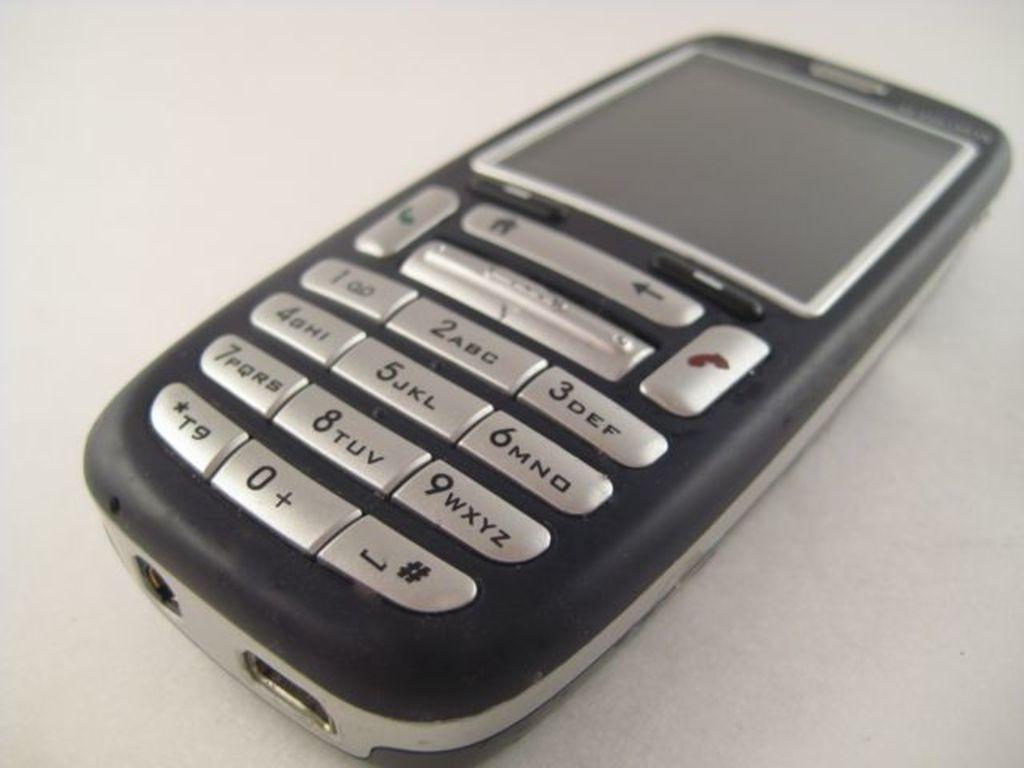Was this phone difficult to type on?
Your answer should be compact. Yes. What letter and number are on the star key?
Provide a short and direct response. T9. 